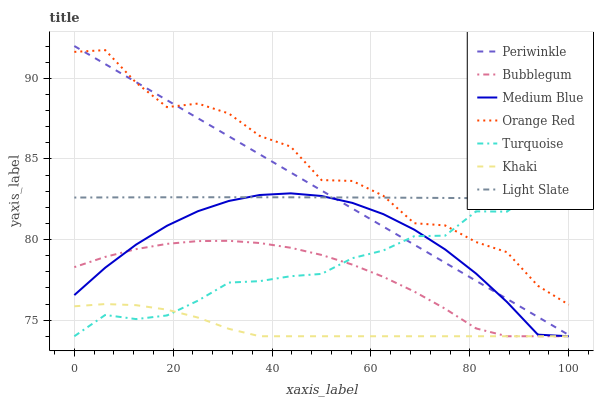Does Khaki have the minimum area under the curve?
Answer yes or no. Yes. Does Light Slate have the minimum area under the curve?
Answer yes or no. No. Does Light Slate have the maximum area under the curve?
Answer yes or no. No. Is Khaki the smoothest?
Answer yes or no. No. Is Khaki the roughest?
Answer yes or no. No. Does Light Slate have the lowest value?
Answer yes or no. No. Does Light Slate have the highest value?
Answer yes or no. No. Is Khaki less than Orange Red?
Answer yes or no. Yes. Is Periwinkle greater than Khaki?
Answer yes or no. Yes. Does Khaki intersect Orange Red?
Answer yes or no. No. 